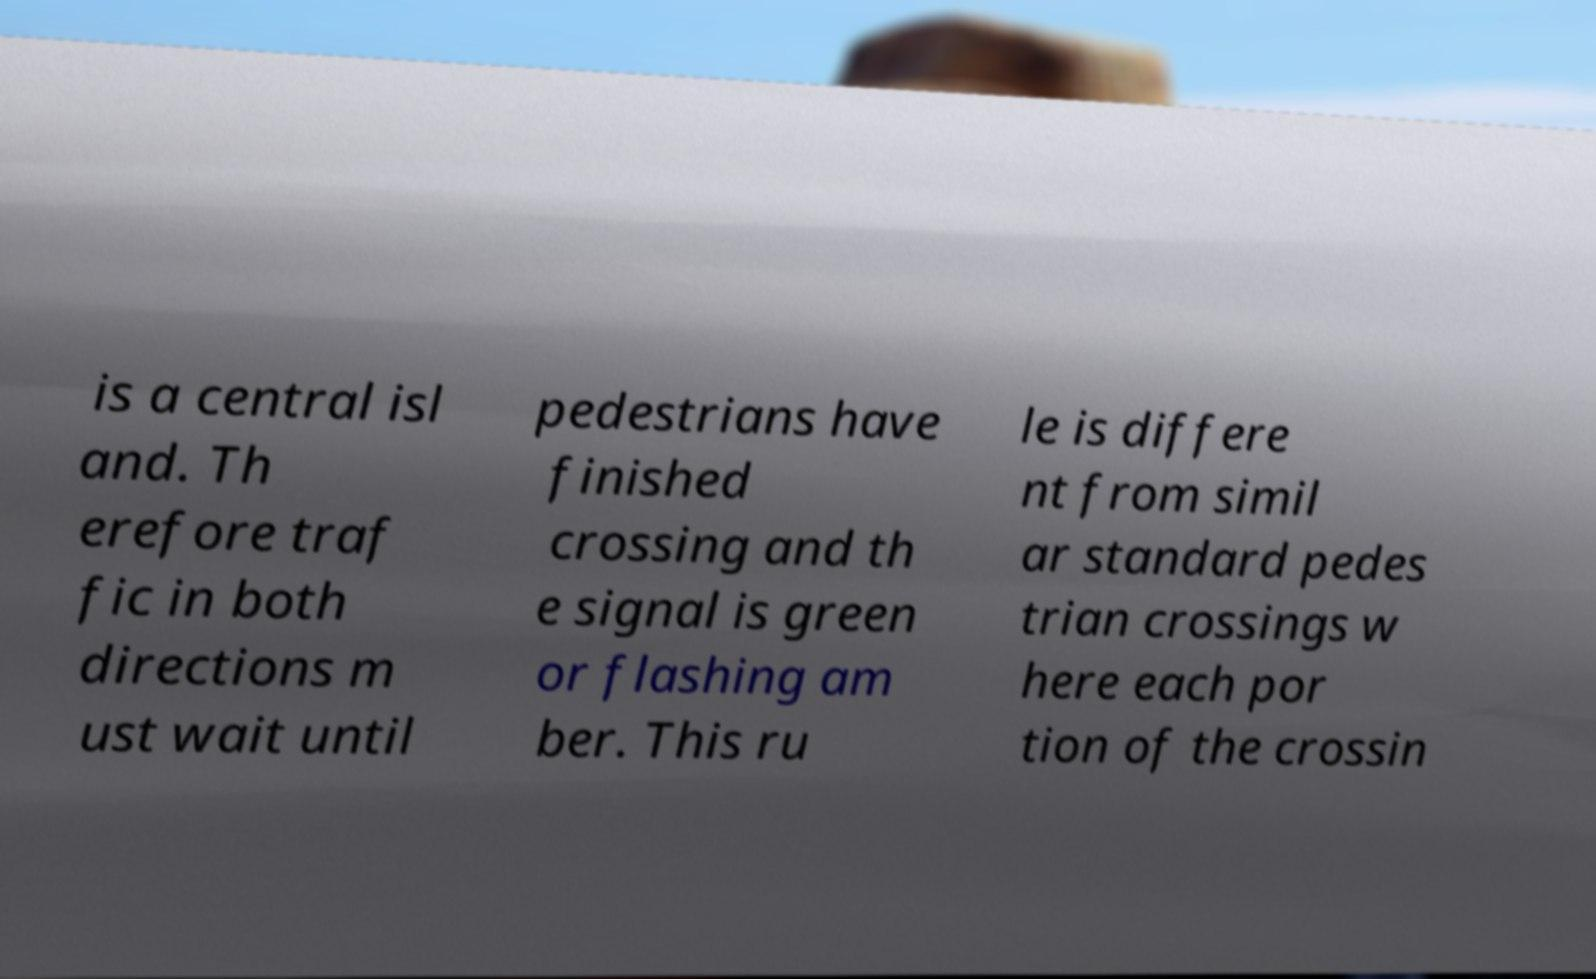Please read and relay the text visible in this image. What does it say? is a central isl and. Th erefore traf fic in both directions m ust wait until pedestrians have finished crossing and th e signal is green or flashing am ber. This ru le is differe nt from simil ar standard pedes trian crossings w here each por tion of the crossin 